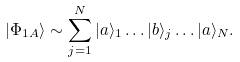Convert formula to latex. <formula><loc_0><loc_0><loc_500><loc_500>| \Phi _ { 1 A } \rangle \sim \sum _ { j = 1 } ^ { N } | a \rangle _ { 1 } \dots | b \rangle _ { j } \dots | a \rangle _ { N } .</formula> 